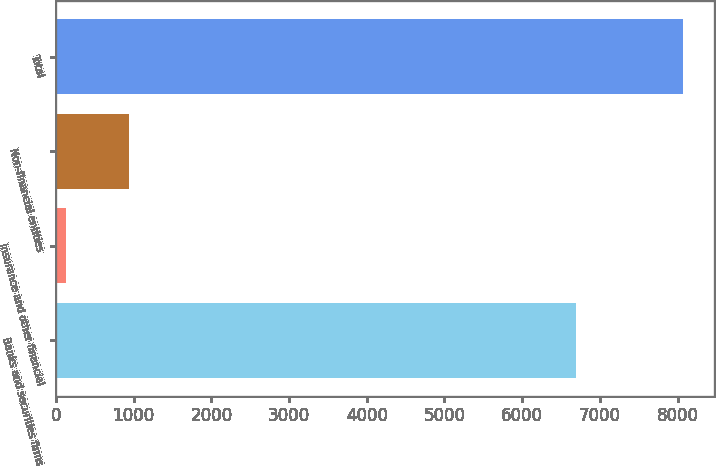Convert chart. <chart><loc_0><loc_0><loc_500><loc_500><bar_chart><fcel>Banks and securities firms<fcel>Insurance and other financial<fcel>Non-financial entities<fcel>Total<nl><fcel>6696<fcel>133<fcel>943<fcel>8065<nl></chart> 